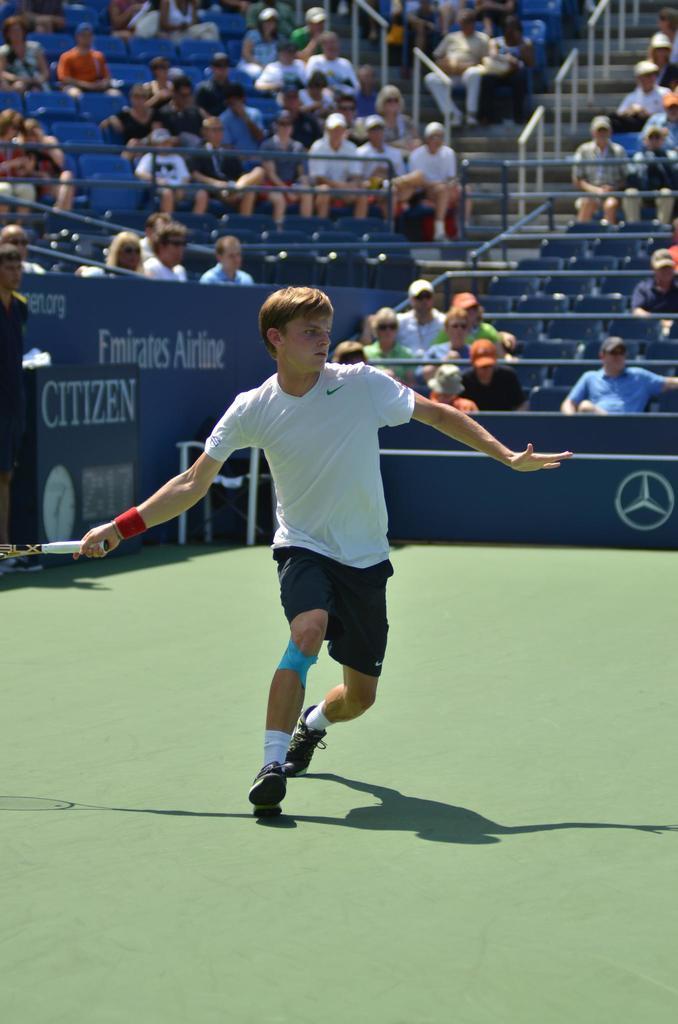Please provide a concise description of this image. In this image, we can see a person is running on the court and holding an object. In the background, we can see people are sitting on the seats. Here we can see banners, table and rods. 